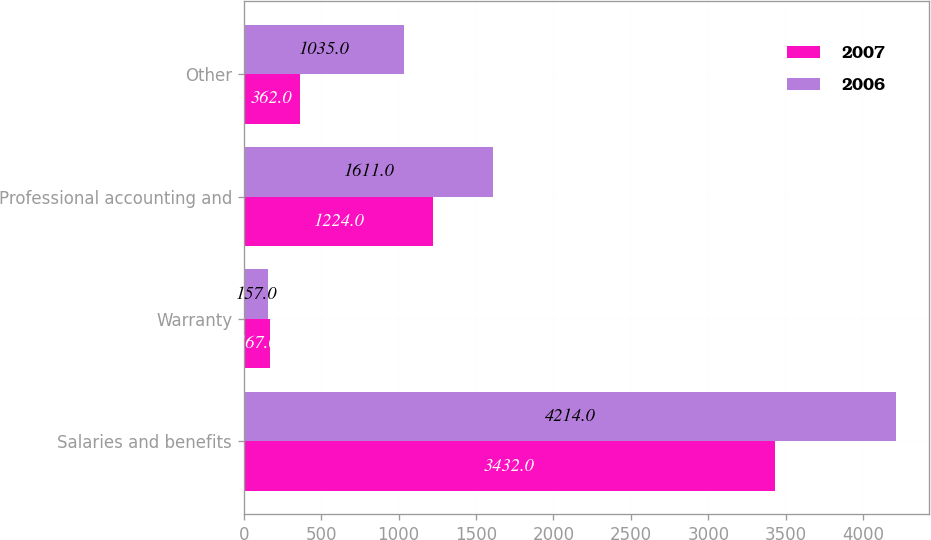<chart> <loc_0><loc_0><loc_500><loc_500><stacked_bar_chart><ecel><fcel>Salaries and benefits<fcel>Warranty<fcel>Professional accounting and<fcel>Other<nl><fcel>2007<fcel>3432<fcel>167<fcel>1224<fcel>362<nl><fcel>2006<fcel>4214<fcel>157<fcel>1611<fcel>1035<nl></chart> 